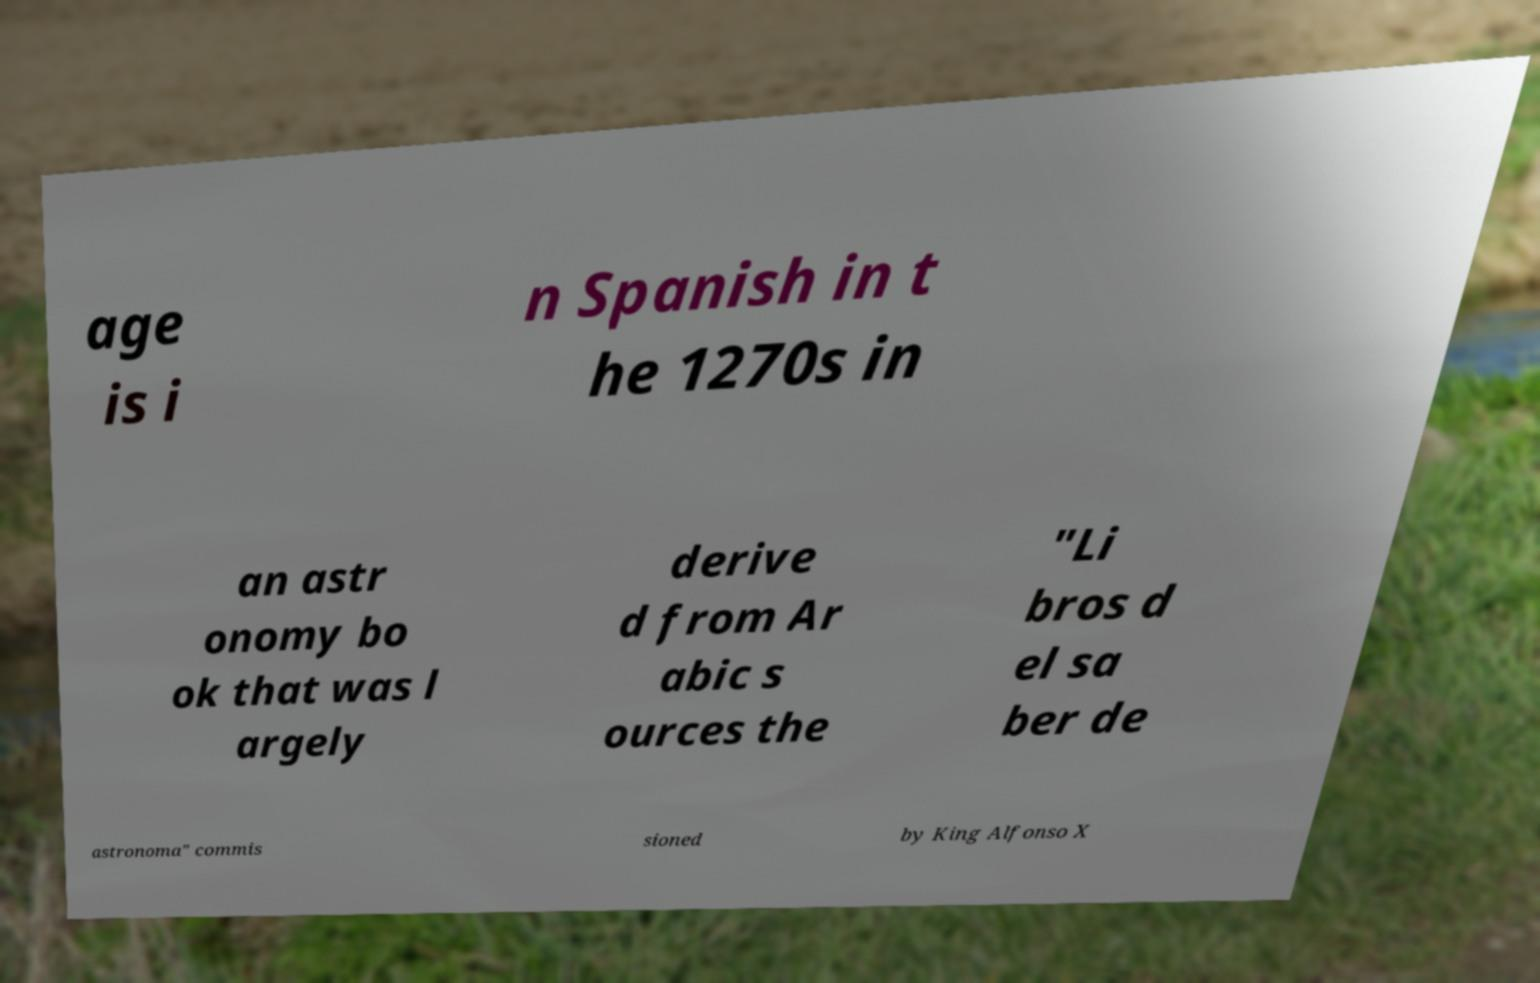For documentation purposes, I need the text within this image transcribed. Could you provide that? age is i n Spanish in t he 1270s in an astr onomy bo ok that was l argely derive d from Ar abic s ources the "Li bros d el sa ber de astronoma" commis sioned by King Alfonso X 